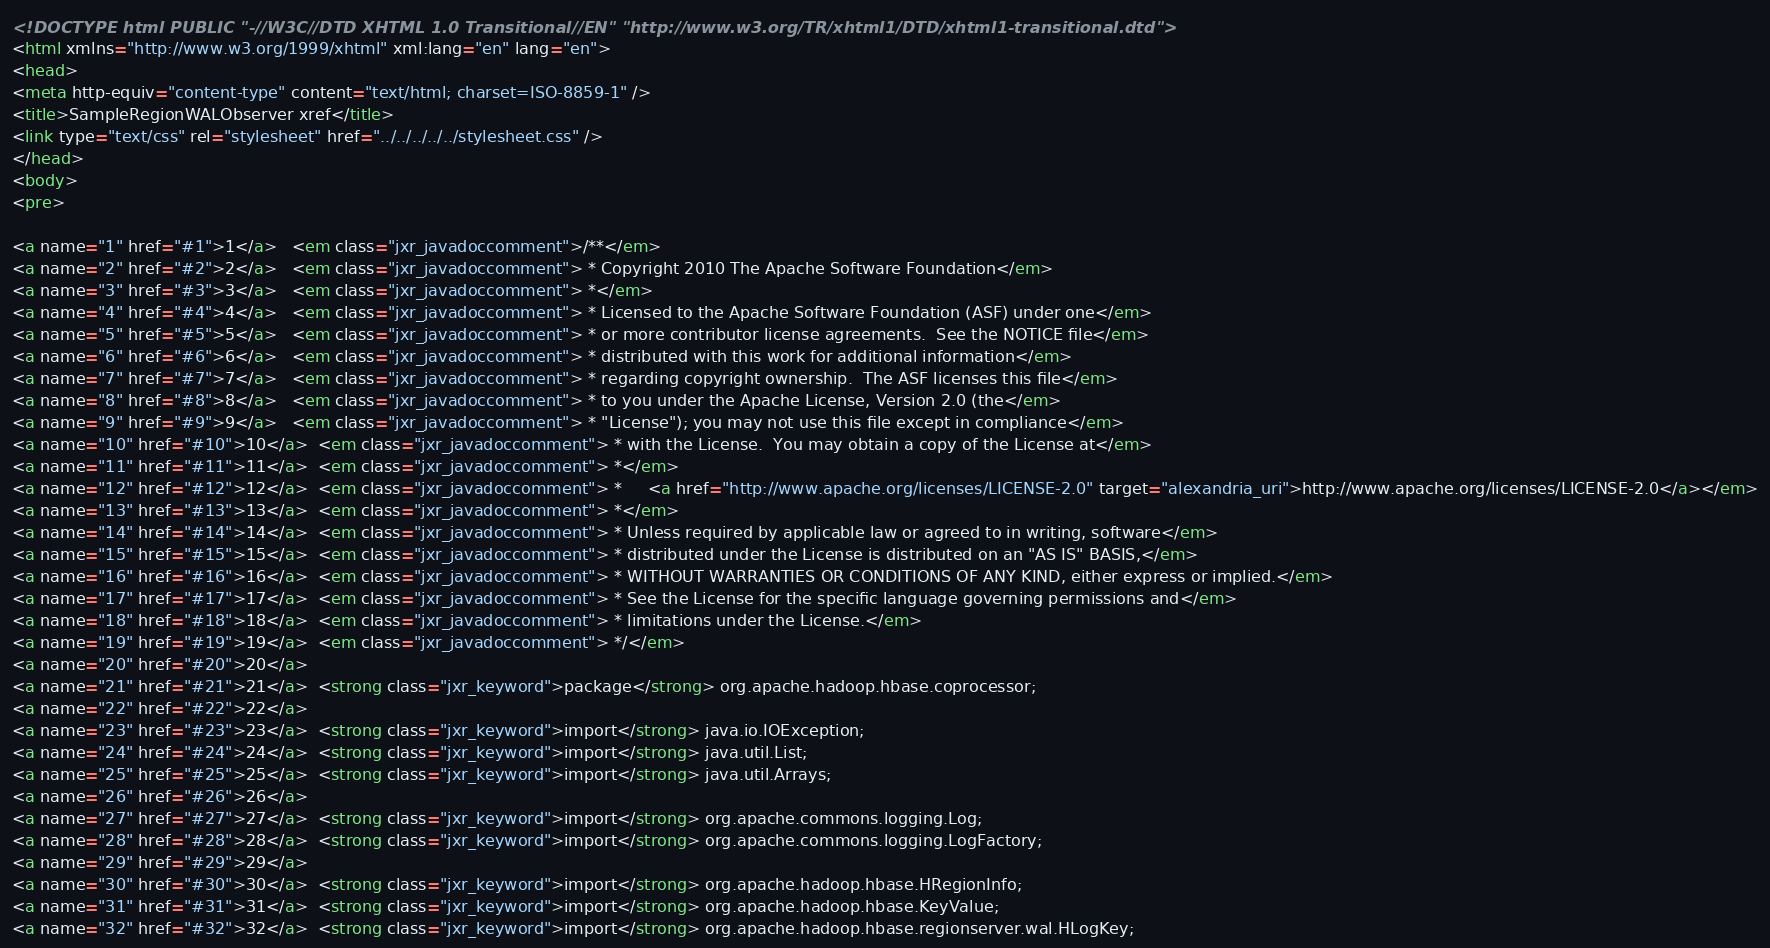<code> <loc_0><loc_0><loc_500><loc_500><_HTML_><!DOCTYPE html PUBLIC "-//W3C//DTD XHTML 1.0 Transitional//EN" "http://www.w3.org/TR/xhtml1/DTD/xhtml1-transitional.dtd">
<html xmlns="http://www.w3.org/1999/xhtml" xml:lang="en" lang="en">
<head>
<meta http-equiv="content-type" content="text/html; charset=ISO-8859-1" />
<title>SampleRegionWALObserver xref</title>
<link type="text/css" rel="stylesheet" href="../../../../../stylesheet.css" />
</head>
<body>
<pre>

<a name="1" href="#1">1</a>   <em class="jxr_javadoccomment">/**</em>
<a name="2" href="#2">2</a>   <em class="jxr_javadoccomment"> * Copyright 2010 The Apache Software Foundation</em>
<a name="3" href="#3">3</a>   <em class="jxr_javadoccomment"> *</em>
<a name="4" href="#4">4</a>   <em class="jxr_javadoccomment"> * Licensed to the Apache Software Foundation (ASF) under one</em>
<a name="5" href="#5">5</a>   <em class="jxr_javadoccomment"> * or more contributor license agreements.  See the NOTICE file</em>
<a name="6" href="#6">6</a>   <em class="jxr_javadoccomment"> * distributed with this work for additional information</em>
<a name="7" href="#7">7</a>   <em class="jxr_javadoccomment"> * regarding copyright ownership.  The ASF licenses this file</em>
<a name="8" href="#8">8</a>   <em class="jxr_javadoccomment"> * to you under the Apache License, Version 2.0 (the</em>
<a name="9" href="#9">9</a>   <em class="jxr_javadoccomment"> * "License"); you may not use this file except in compliance</em>
<a name="10" href="#10">10</a>  <em class="jxr_javadoccomment"> * with the License.  You may obtain a copy of the License at</em>
<a name="11" href="#11">11</a>  <em class="jxr_javadoccomment"> *</em>
<a name="12" href="#12">12</a>  <em class="jxr_javadoccomment"> *     <a href="http://www.apache.org/licenses/LICENSE-2.0" target="alexandria_uri">http://www.apache.org/licenses/LICENSE-2.0</a></em>
<a name="13" href="#13">13</a>  <em class="jxr_javadoccomment"> *</em>
<a name="14" href="#14">14</a>  <em class="jxr_javadoccomment"> * Unless required by applicable law or agreed to in writing, software</em>
<a name="15" href="#15">15</a>  <em class="jxr_javadoccomment"> * distributed under the License is distributed on an "AS IS" BASIS,</em>
<a name="16" href="#16">16</a>  <em class="jxr_javadoccomment"> * WITHOUT WARRANTIES OR CONDITIONS OF ANY KIND, either express or implied.</em>
<a name="17" href="#17">17</a>  <em class="jxr_javadoccomment"> * See the License for the specific language governing permissions and</em>
<a name="18" href="#18">18</a>  <em class="jxr_javadoccomment"> * limitations under the License.</em>
<a name="19" href="#19">19</a>  <em class="jxr_javadoccomment"> */</em>
<a name="20" href="#20">20</a>  
<a name="21" href="#21">21</a>  <strong class="jxr_keyword">package</strong> org.apache.hadoop.hbase.coprocessor;
<a name="22" href="#22">22</a>  
<a name="23" href="#23">23</a>  <strong class="jxr_keyword">import</strong> java.io.IOException;
<a name="24" href="#24">24</a>  <strong class="jxr_keyword">import</strong> java.util.List;
<a name="25" href="#25">25</a>  <strong class="jxr_keyword">import</strong> java.util.Arrays;
<a name="26" href="#26">26</a>  
<a name="27" href="#27">27</a>  <strong class="jxr_keyword">import</strong> org.apache.commons.logging.Log;
<a name="28" href="#28">28</a>  <strong class="jxr_keyword">import</strong> org.apache.commons.logging.LogFactory;
<a name="29" href="#29">29</a>  
<a name="30" href="#30">30</a>  <strong class="jxr_keyword">import</strong> org.apache.hadoop.hbase.HRegionInfo;
<a name="31" href="#31">31</a>  <strong class="jxr_keyword">import</strong> org.apache.hadoop.hbase.KeyValue;
<a name="32" href="#32">32</a>  <strong class="jxr_keyword">import</strong> org.apache.hadoop.hbase.regionserver.wal.HLogKey;</code> 